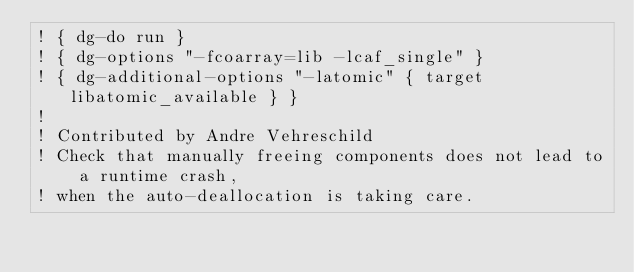<code> <loc_0><loc_0><loc_500><loc_500><_FORTRAN_>! { dg-do run }
! { dg-options "-fcoarray=lib -lcaf_single" }
! { dg-additional-options "-latomic" { target libatomic_available } }
!
! Contributed by Andre Vehreschild
! Check that manually freeing components does not lead to a runtime crash,
! when the auto-deallocation is taking care.
</code> 